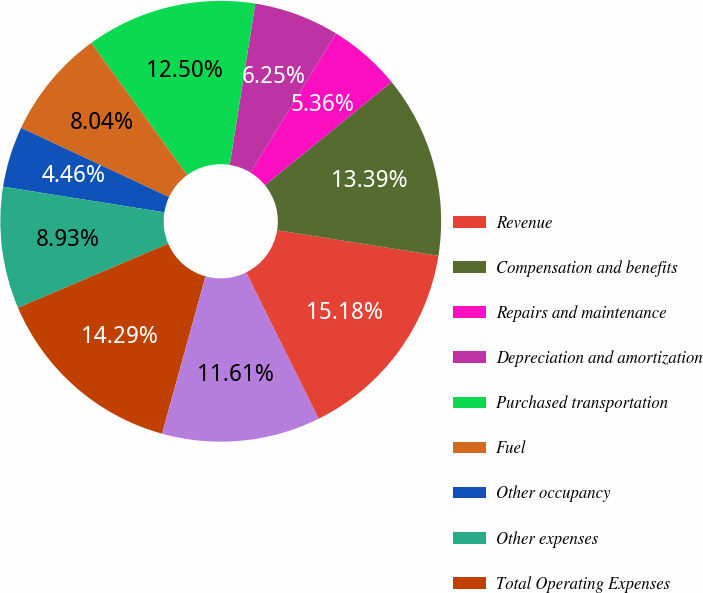Convert chart to OTSL. <chart><loc_0><loc_0><loc_500><loc_500><pie_chart><fcel>Revenue<fcel>Compensation and benefits<fcel>Repairs and maintenance<fcel>Depreciation and amortization<fcel>Purchased transportation<fcel>Fuel<fcel>Other occupancy<fcel>Other expenses<fcel>Total Operating Expenses<fcel>Operating Profit<nl><fcel>15.18%<fcel>13.39%<fcel>5.36%<fcel>6.25%<fcel>12.5%<fcel>8.04%<fcel>4.46%<fcel>8.93%<fcel>14.29%<fcel>11.61%<nl></chart> 